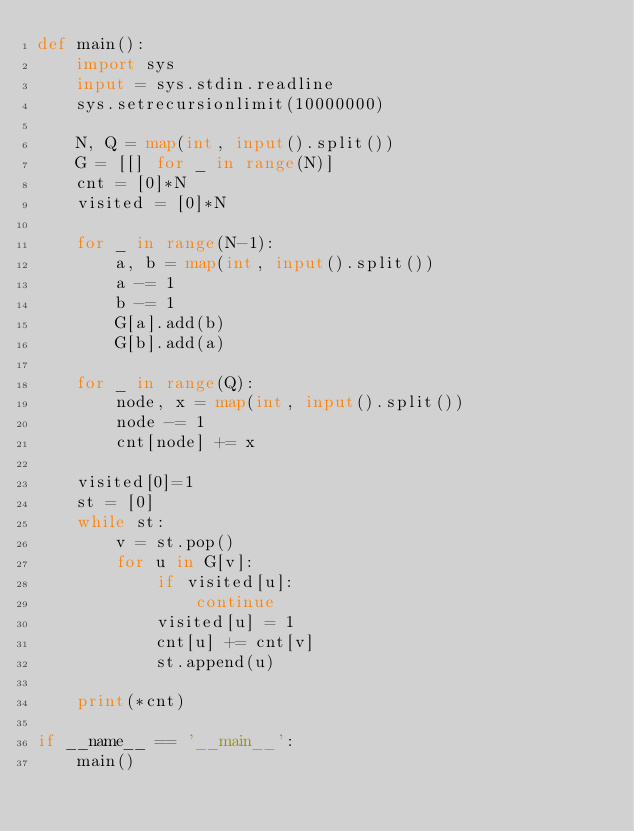<code> <loc_0><loc_0><loc_500><loc_500><_Python_>def main():
    import sys
    input = sys.stdin.readline
    sys.setrecursionlimit(10000000)

    N, Q = map(int, input().split())
    G = [[] for _ in range(N)]
    cnt = [0]*N
    visited = [0]*N

    for _ in range(N-1):
        a, b = map(int, input().split())
        a -= 1
        b -= 1
        G[a].add(b)
        G[b].add(a)

    for _ in range(Q):
        node, x = map(int, input().split())
        node -= 1
        cnt[node] += x

    visited[0]=1
    st = [0]
    while st:
        v = st.pop()
        for u in G[v]:
            if visited[u]:
                continue
            visited[u] = 1
            cnt[u] += cnt[v]
            st.append(u)    

    print(*cnt)

if __name__ == '__main__':
    main()

</code> 